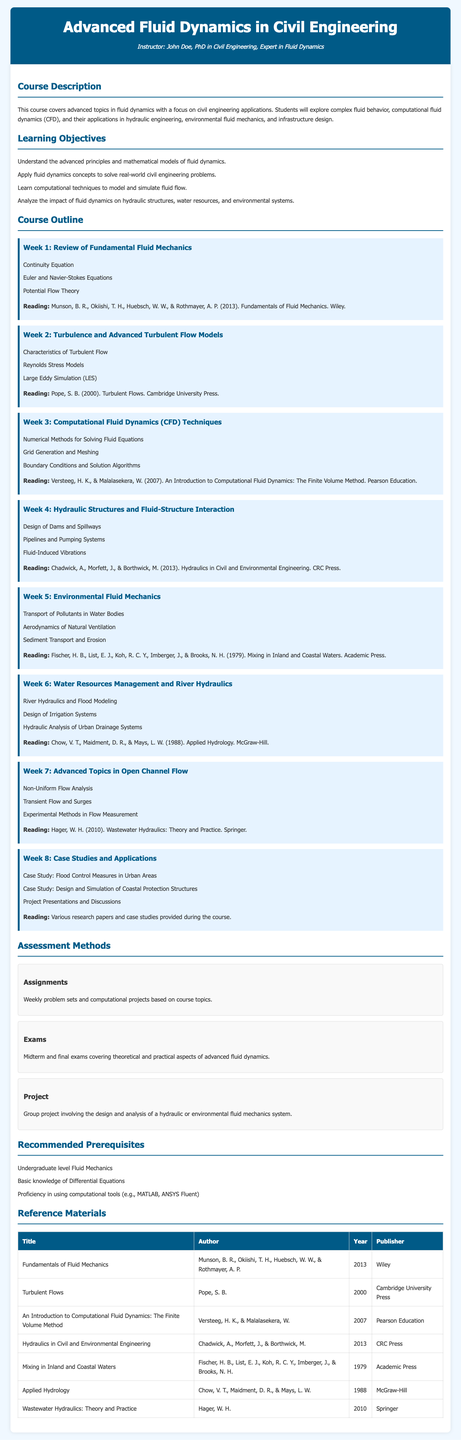What is the title of the course? The title of the course is given in the header section of the document.
Answer: Advanced Fluid Dynamics in Civil Engineering Who is the instructor of the course? The instructor's name and credentials are mentioned in the header section.
Answer: John Doe, PhD in Civil Engineering, Expert in Fluid Dynamics What is the main focus of the course? The course description outlines the main focus of the syllabus.
Answer: Advanced topics in fluid dynamics with a focus on civil engineering applications How many weeks does the course outline cover? The weekly topics indicate the total number of weeks in the course outline.
Answer: Eight weeks What is one of the assessed project types in the course? The assessment section mentions different project types throughout the course.
Answer: Group project What is the prerequisite level of Fluid Mechanics required for this course? The prerequisites section specifically asks about the level of study required.
Answer: Undergraduate level Fluid Mechanics What is the reading material for Week 2? Each week has a designated reading material listed at the end of the week’s topics.
Answer: Pope, S. B. (2000). Turbulent Flows. Cambridge University Press What computational tools should students be proficient in? The prerequisites section lists specific tools needed for the course.
Answer: MATLAB, ANSYS Fluent What type of flow analysis is discussed in Week 7? Week 7 topics provide specific types of flow analysis to be studied.
Answer: Non-Uniform Flow Analysis 